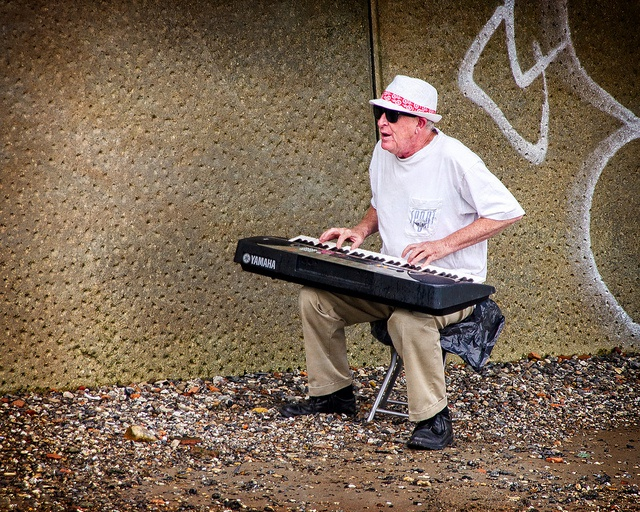Describe the objects in this image and their specific colors. I can see people in black, lavender, lightpink, and darkgray tones, chair in black and gray tones, and chair in black, gray, and darkgray tones in this image. 